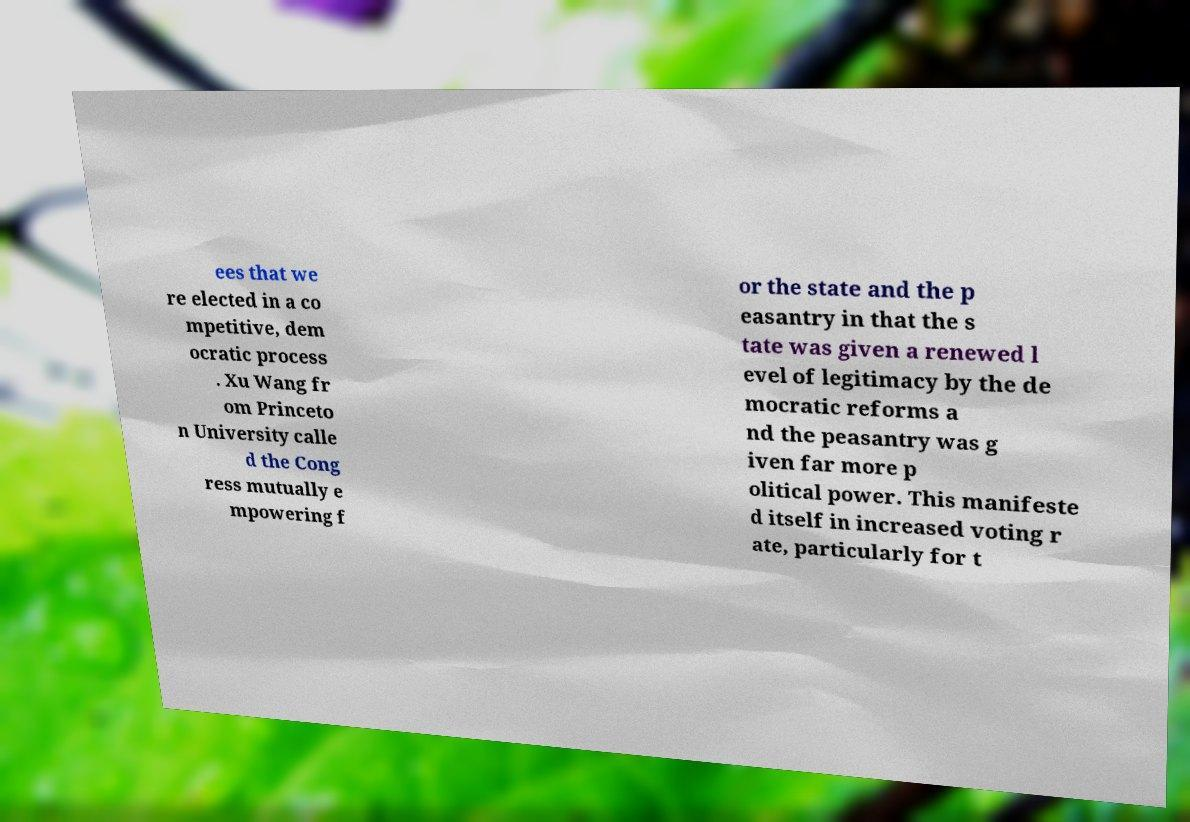Could you extract and type out the text from this image? ees that we re elected in a co mpetitive, dem ocratic process . Xu Wang fr om Princeto n University calle d the Cong ress mutually e mpowering f or the state and the p easantry in that the s tate was given a renewed l evel of legitimacy by the de mocratic reforms a nd the peasantry was g iven far more p olitical power. This manifeste d itself in increased voting r ate, particularly for t 